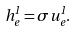<formula> <loc_0><loc_0><loc_500><loc_500>h _ { e } ^ { 1 } = \sigma u _ { e } ^ { 1 } .</formula> 